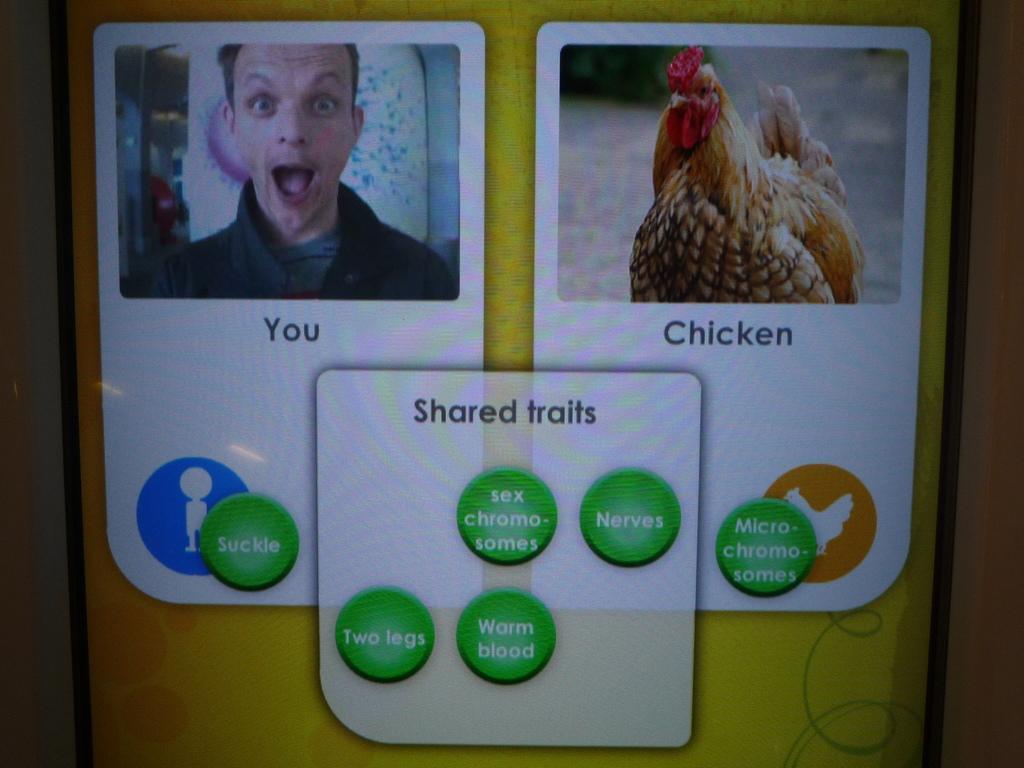How would you summarize this image in a sentence or two? In this image I can see the screen. In the screen I can see a person face and a bird and the bird is in brown and cream color, and I can see something written on the screen. 